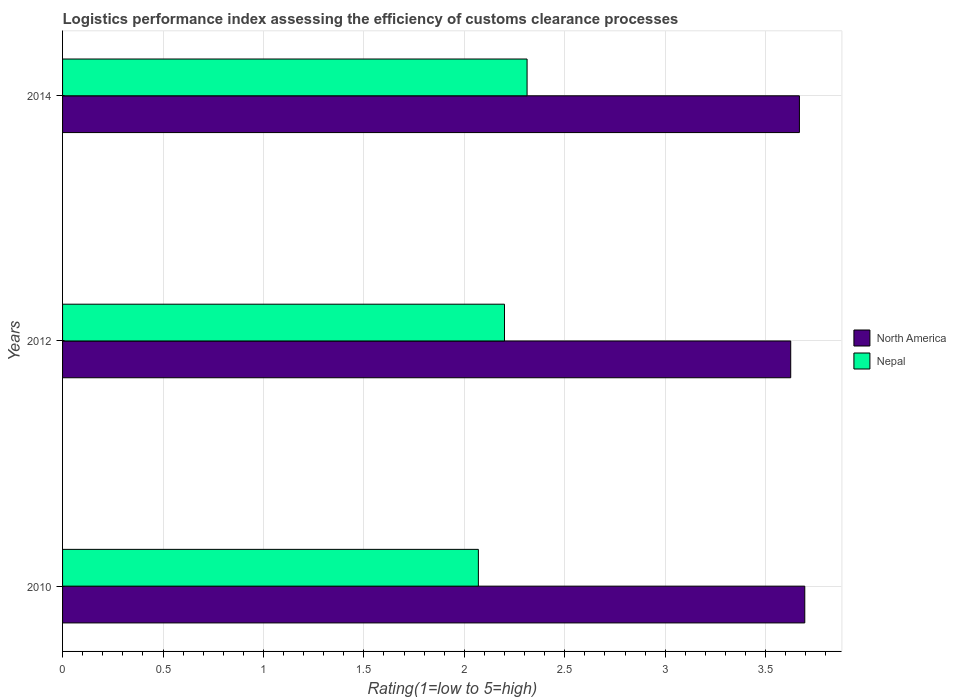How many different coloured bars are there?
Your response must be concise. 2. How many groups of bars are there?
Offer a very short reply. 3. Are the number of bars per tick equal to the number of legend labels?
Keep it short and to the point. Yes. How many bars are there on the 3rd tick from the top?
Provide a succinct answer. 2. What is the label of the 1st group of bars from the top?
Provide a succinct answer. 2014. In how many cases, is the number of bars for a given year not equal to the number of legend labels?
Offer a terse response. 0. What is the Logistic performance index in Nepal in 2014?
Offer a terse response. 2.31. Across all years, what is the maximum Logistic performance index in Nepal?
Ensure brevity in your answer.  2.31. Across all years, what is the minimum Logistic performance index in North America?
Make the answer very short. 3.62. In which year was the Logistic performance index in Nepal maximum?
Provide a short and direct response. 2014. In which year was the Logistic performance index in Nepal minimum?
Offer a terse response. 2010. What is the total Logistic performance index in North America in the graph?
Offer a very short reply. 10.99. What is the difference between the Logistic performance index in North America in 2012 and that in 2014?
Offer a very short reply. -0.04. What is the difference between the Logistic performance index in Nepal in 2010 and the Logistic performance index in North America in 2012?
Offer a terse response. -1.56. What is the average Logistic performance index in North America per year?
Offer a terse response. 3.66. In the year 2010, what is the difference between the Logistic performance index in North America and Logistic performance index in Nepal?
Keep it short and to the point. 1.62. In how many years, is the Logistic performance index in North America greater than 2.3 ?
Give a very brief answer. 3. What is the ratio of the Logistic performance index in Nepal in 2010 to that in 2012?
Give a very brief answer. 0.94. Is the difference between the Logistic performance index in North America in 2010 and 2012 greater than the difference between the Logistic performance index in Nepal in 2010 and 2012?
Your answer should be compact. Yes. What is the difference between the highest and the second highest Logistic performance index in Nepal?
Ensure brevity in your answer.  0.11. What is the difference between the highest and the lowest Logistic performance index in North America?
Your response must be concise. 0.07. What does the 2nd bar from the top in 2014 represents?
Offer a terse response. North America. What does the 2nd bar from the bottom in 2012 represents?
Your response must be concise. Nepal. How many years are there in the graph?
Offer a terse response. 3. What is the difference between two consecutive major ticks on the X-axis?
Provide a succinct answer. 0.5. Are the values on the major ticks of X-axis written in scientific E-notation?
Offer a terse response. No. Does the graph contain any zero values?
Provide a succinct answer. No. Where does the legend appear in the graph?
Provide a succinct answer. Center right. How many legend labels are there?
Provide a short and direct response. 2. How are the legend labels stacked?
Ensure brevity in your answer.  Vertical. What is the title of the graph?
Your answer should be very brief. Logistics performance index assessing the efficiency of customs clearance processes. Does "St. Kitts and Nevis" appear as one of the legend labels in the graph?
Your response must be concise. No. What is the label or title of the X-axis?
Make the answer very short. Rating(1=low to 5=high). What is the label or title of the Y-axis?
Make the answer very short. Years. What is the Rating(1=low to 5=high) of North America in 2010?
Provide a succinct answer. 3.69. What is the Rating(1=low to 5=high) in Nepal in 2010?
Provide a succinct answer. 2.07. What is the Rating(1=low to 5=high) of North America in 2012?
Your answer should be compact. 3.62. What is the Rating(1=low to 5=high) of Nepal in 2012?
Offer a terse response. 2.2. What is the Rating(1=low to 5=high) in North America in 2014?
Your answer should be very brief. 3.67. What is the Rating(1=low to 5=high) in Nepal in 2014?
Offer a very short reply. 2.31. Across all years, what is the maximum Rating(1=low to 5=high) of North America?
Make the answer very short. 3.69. Across all years, what is the maximum Rating(1=low to 5=high) in Nepal?
Your response must be concise. 2.31. Across all years, what is the minimum Rating(1=low to 5=high) of North America?
Ensure brevity in your answer.  3.62. Across all years, what is the minimum Rating(1=low to 5=high) in Nepal?
Offer a very short reply. 2.07. What is the total Rating(1=low to 5=high) of North America in the graph?
Offer a terse response. 10.99. What is the total Rating(1=low to 5=high) in Nepal in the graph?
Your answer should be compact. 6.58. What is the difference between the Rating(1=low to 5=high) in North America in 2010 and that in 2012?
Make the answer very short. 0.07. What is the difference between the Rating(1=low to 5=high) of Nepal in 2010 and that in 2012?
Provide a short and direct response. -0.13. What is the difference between the Rating(1=low to 5=high) of North America in 2010 and that in 2014?
Offer a very short reply. 0.03. What is the difference between the Rating(1=low to 5=high) of Nepal in 2010 and that in 2014?
Offer a very short reply. -0.24. What is the difference between the Rating(1=low to 5=high) in North America in 2012 and that in 2014?
Keep it short and to the point. -0.04. What is the difference between the Rating(1=low to 5=high) in Nepal in 2012 and that in 2014?
Provide a short and direct response. -0.11. What is the difference between the Rating(1=low to 5=high) of North America in 2010 and the Rating(1=low to 5=high) of Nepal in 2012?
Give a very brief answer. 1.5. What is the difference between the Rating(1=low to 5=high) in North America in 2010 and the Rating(1=low to 5=high) in Nepal in 2014?
Make the answer very short. 1.38. What is the difference between the Rating(1=low to 5=high) in North America in 2012 and the Rating(1=low to 5=high) in Nepal in 2014?
Offer a terse response. 1.31. What is the average Rating(1=low to 5=high) of North America per year?
Your response must be concise. 3.66. What is the average Rating(1=low to 5=high) in Nepal per year?
Provide a succinct answer. 2.19. In the year 2010, what is the difference between the Rating(1=low to 5=high) of North America and Rating(1=low to 5=high) of Nepal?
Keep it short and to the point. 1.62. In the year 2012, what is the difference between the Rating(1=low to 5=high) of North America and Rating(1=low to 5=high) of Nepal?
Your response must be concise. 1.43. In the year 2014, what is the difference between the Rating(1=low to 5=high) of North America and Rating(1=low to 5=high) of Nepal?
Ensure brevity in your answer.  1.36. What is the ratio of the Rating(1=low to 5=high) of North America in 2010 to that in 2012?
Provide a succinct answer. 1.02. What is the ratio of the Rating(1=low to 5=high) of Nepal in 2010 to that in 2012?
Your response must be concise. 0.94. What is the ratio of the Rating(1=low to 5=high) in North America in 2010 to that in 2014?
Give a very brief answer. 1.01. What is the ratio of the Rating(1=low to 5=high) in Nepal in 2010 to that in 2014?
Provide a short and direct response. 0.9. What is the ratio of the Rating(1=low to 5=high) in North America in 2012 to that in 2014?
Provide a short and direct response. 0.99. What is the ratio of the Rating(1=low to 5=high) in Nepal in 2012 to that in 2014?
Your answer should be very brief. 0.95. What is the difference between the highest and the second highest Rating(1=low to 5=high) of North America?
Your answer should be compact. 0.03. What is the difference between the highest and the second highest Rating(1=low to 5=high) in Nepal?
Your response must be concise. 0.11. What is the difference between the highest and the lowest Rating(1=low to 5=high) in North America?
Provide a short and direct response. 0.07. What is the difference between the highest and the lowest Rating(1=low to 5=high) in Nepal?
Your answer should be very brief. 0.24. 